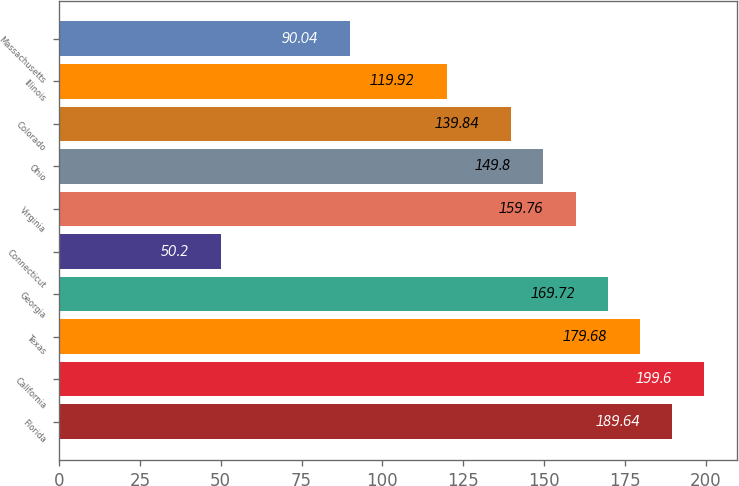Convert chart. <chart><loc_0><loc_0><loc_500><loc_500><bar_chart><fcel>Florida<fcel>California<fcel>Texas<fcel>Georgia<fcel>Connecticut<fcel>Virginia<fcel>Ohio<fcel>Colorado<fcel>Illinois<fcel>Massachusetts<nl><fcel>189.64<fcel>199.6<fcel>179.68<fcel>169.72<fcel>50.2<fcel>159.76<fcel>149.8<fcel>139.84<fcel>119.92<fcel>90.04<nl></chart> 